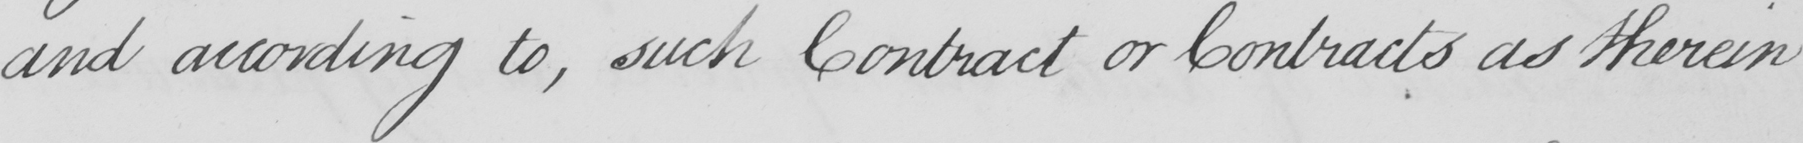What does this handwritten line say? and according to , such Contract or Contracts as therein 